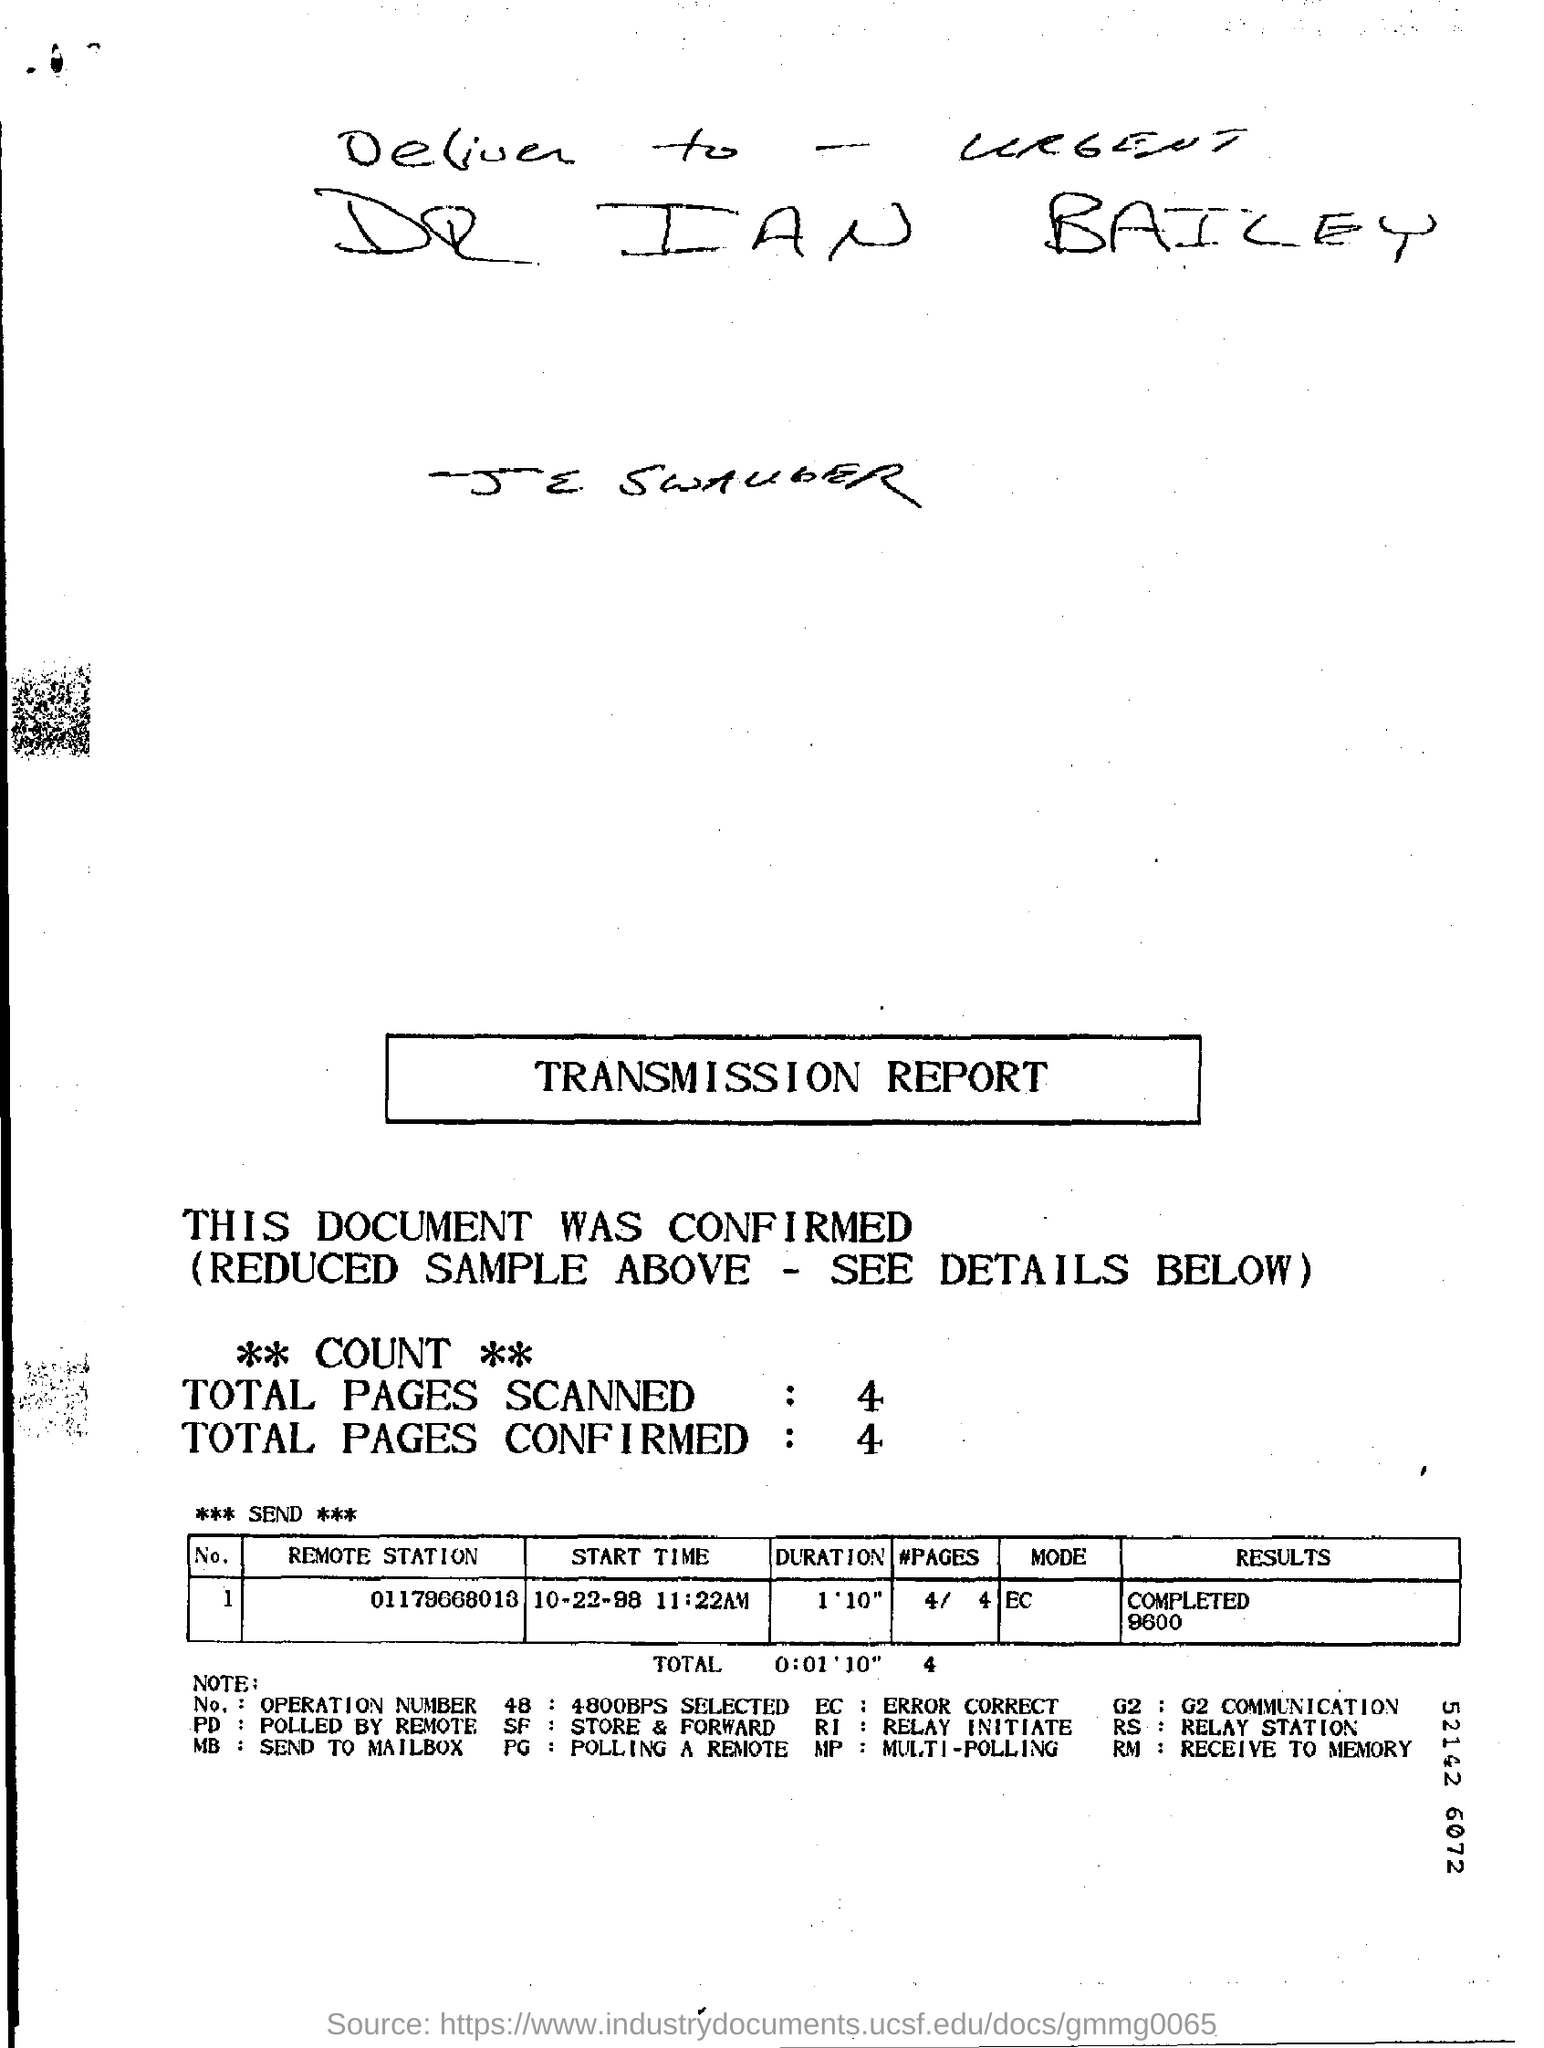What is mode of transmission?
Give a very brief answer. EC. 